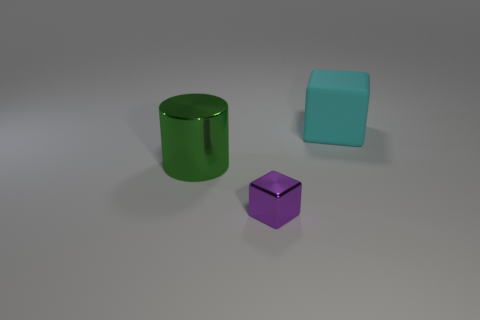What number of big objects are green cylinders or blocks? 2 